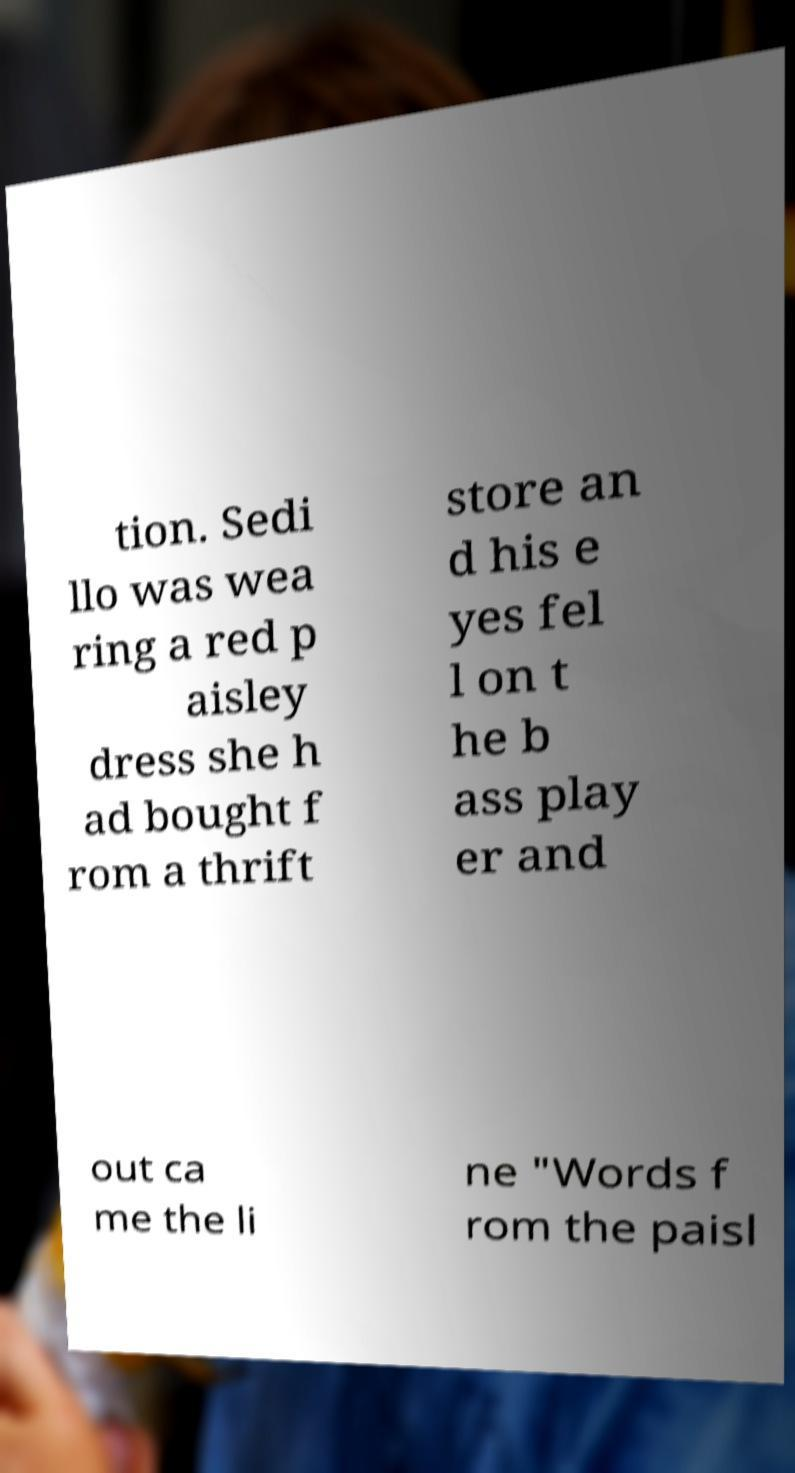There's text embedded in this image that I need extracted. Can you transcribe it verbatim? tion. Sedi llo was wea ring a red p aisley dress she h ad bought f rom a thrift store an d his e yes fel l on t he b ass play er and out ca me the li ne "Words f rom the paisl 